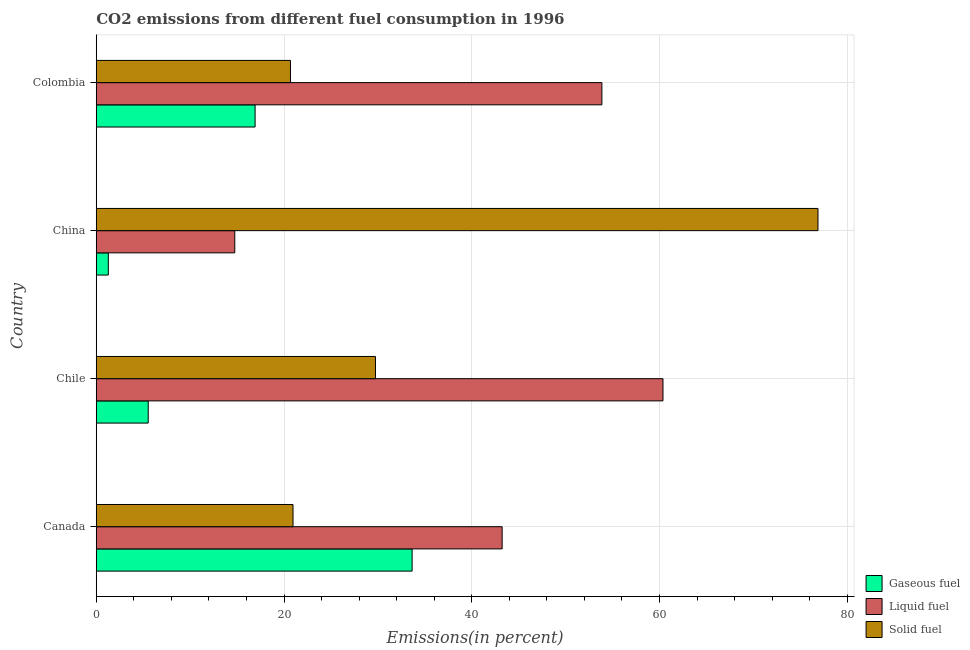How many groups of bars are there?
Offer a terse response. 4. Are the number of bars on each tick of the Y-axis equal?
Keep it short and to the point. Yes. How many bars are there on the 4th tick from the top?
Make the answer very short. 3. How many bars are there on the 2nd tick from the bottom?
Make the answer very short. 3. What is the label of the 3rd group of bars from the top?
Your answer should be compact. Chile. What is the percentage of liquid fuel emission in China?
Offer a terse response. 14.76. Across all countries, what is the maximum percentage of gaseous fuel emission?
Your response must be concise. 33.65. Across all countries, what is the minimum percentage of liquid fuel emission?
Your answer should be compact. 14.76. In which country was the percentage of gaseous fuel emission maximum?
Your answer should be compact. Canada. What is the total percentage of liquid fuel emission in the graph?
Your answer should be very brief. 172.23. What is the difference between the percentage of solid fuel emission in Canada and that in Colombia?
Ensure brevity in your answer.  0.27. What is the difference between the percentage of liquid fuel emission in Colombia and the percentage of solid fuel emission in Canada?
Provide a short and direct response. 32.9. What is the average percentage of liquid fuel emission per country?
Ensure brevity in your answer.  43.06. What is the difference between the percentage of solid fuel emission and percentage of liquid fuel emission in China?
Provide a short and direct response. 62.13. What is the ratio of the percentage of gaseous fuel emission in Chile to that in China?
Make the answer very short. 4.31. Is the difference between the percentage of liquid fuel emission in China and Colombia greater than the difference between the percentage of solid fuel emission in China and Colombia?
Your answer should be very brief. No. What is the difference between the highest and the second highest percentage of liquid fuel emission?
Provide a succinct answer. 6.51. What is the difference between the highest and the lowest percentage of liquid fuel emission?
Ensure brevity in your answer.  45.62. In how many countries, is the percentage of solid fuel emission greater than the average percentage of solid fuel emission taken over all countries?
Your response must be concise. 1. Is the sum of the percentage of gaseous fuel emission in China and Colombia greater than the maximum percentage of solid fuel emission across all countries?
Ensure brevity in your answer.  No. What does the 3rd bar from the top in Chile represents?
Provide a short and direct response. Gaseous fuel. What does the 1st bar from the bottom in Chile represents?
Give a very brief answer. Gaseous fuel. Is it the case that in every country, the sum of the percentage of gaseous fuel emission and percentage of liquid fuel emission is greater than the percentage of solid fuel emission?
Offer a terse response. No. How many bars are there?
Keep it short and to the point. 12. Are all the bars in the graph horizontal?
Provide a succinct answer. Yes. Are the values on the major ticks of X-axis written in scientific E-notation?
Give a very brief answer. No. Does the graph contain any zero values?
Make the answer very short. No. How many legend labels are there?
Make the answer very short. 3. What is the title of the graph?
Provide a succinct answer. CO2 emissions from different fuel consumption in 1996. What is the label or title of the X-axis?
Offer a very short reply. Emissions(in percent). What is the Emissions(in percent) in Gaseous fuel in Canada?
Offer a very short reply. 33.65. What is the Emissions(in percent) in Liquid fuel in Canada?
Provide a short and direct response. 43.24. What is the Emissions(in percent) in Solid fuel in Canada?
Offer a terse response. 20.96. What is the Emissions(in percent) of Gaseous fuel in Chile?
Your answer should be compact. 5.53. What is the Emissions(in percent) of Liquid fuel in Chile?
Your answer should be compact. 60.37. What is the Emissions(in percent) in Solid fuel in Chile?
Offer a very short reply. 29.74. What is the Emissions(in percent) in Gaseous fuel in China?
Give a very brief answer. 1.29. What is the Emissions(in percent) of Liquid fuel in China?
Keep it short and to the point. 14.76. What is the Emissions(in percent) in Solid fuel in China?
Give a very brief answer. 76.88. What is the Emissions(in percent) of Gaseous fuel in Colombia?
Offer a very short reply. 16.92. What is the Emissions(in percent) of Liquid fuel in Colombia?
Make the answer very short. 53.87. What is the Emissions(in percent) of Solid fuel in Colombia?
Your answer should be very brief. 20.69. Across all countries, what is the maximum Emissions(in percent) of Gaseous fuel?
Make the answer very short. 33.65. Across all countries, what is the maximum Emissions(in percent) in Liquid fuel?
Your answer should be very brief. 60.37. Across all countries, what is the maximum Emissions(in percent) in Solid fuel?
Provide a succinct answer. 76.88. Across all countries, what is the minimum Emissions(in percent) of Gaseous fuel?
Provide a succinct answer. 1.29. Across all countries, what is the minimum Emissions(in percent) of Liquid fuel?
Keep it short and to the point. 14.76. Across all countries, what is the minimum Emissions(in percent) in Solid fuel?
Offer a very short reply. 20.69. What is the total Emissions(in percent) of Gaseous fuel in the graph?
Keep it short and to the point. 57.39. What is the total Emissions(in percent) in Liquid fuel in the graph?
Provide a short and direct response. 172.23. What is the total Emissions(in percent) in Solid fuel in the graph?
Offer a very short reply. 148.28. What is the difference between the Emissions(in percent) of Gaseous fuel in Canada and that in Chile?
Your answer should be compact. 28.11. What is the difference between the Emissions(in percent) of Liquid fuel in Canada and that in Chile?
Give a very brief answer. -17.13. What is the difference between the Emissions(in percent) of Solid fuel in Canada and that in Chile?
Offer a terse response. -8.78. What is the difference between the Emissions(in percent) of Gaseous fuel in Canada and that in China?
Your response must be concise. 32.36. What is the difference between the Emissions(in percent) in Liquid fuel in Canada and that in China?
Keep it short and to the point. 28.48. What is the difference between the Emissions(in percent) of Solid fuel in Canada and that in China?
Your answer should be very brief. -55.92. What is the difference between the Emissions(in percent) of Gaseous fuel in Canada and that in Colombia?
Make the answer very short. 16.73. What is the difference between the Emissions(in percent) of Liquid fuel in Canada and that in Colombia?
Ensure brevity in your answer.  -10.63. What is the difference between the Emissions(in percent) of Solid fuel in Canada and that in Colombia?
Your response must be concise. 0.27. What is the difference between the Emissions(in percent) in Gaseous fuel in Chile and that in China?
Your answer should be compact. 4.25. What is the difference between the Emissions(in percent) of Liquid fuel in Chile and that in China?
Offer a very short reply. 45.62. What is the difference between the Emissions(in percent) in Solid fuel in Chile and that in China?
Ensure brevity in your answer.  -47.14. What is the difference between the Emissions(in percent) of Gaseous fuel in Chile and that in Colombia?
Offer a very short reply. -11.39. What is the difference between the Emissions(in percent) in Liquid fuel in Chile and that in Colombia?
Ensure brevity in your answer.  6.51. What is the difference between the Emissions(in percent) in Solid fuel in Chile and that in Colombia?
Provide a short and direct response. 9.05. What is the difference between the Emissions(in percent) of Gaseous fuel in China and that in Colombia?
Make the answer very short. -15.64. What is the difference between the Emissions(in percent) in Liquid fuel in China and that in Colombia?
Make the answer very short. -39.11. What is the difference between the Emissions(in percent) of Solid fuel in China and that in Colombia?
Give a very brief answer. 56.2. What is the difference between the Emissions(in percent) in Gaseous fuel in Canada and the Emissions(in percent) in Liquid fuel in Chile?
Your answer should be very brief. -26.73. What is the difference between the Emissions(in percent) in Gaseous fuel in Canada and the Emissions(in percent) in Solid fuel in Chile?
Provide a short and direct response. 3.9. What is the difference between the Emissions(in percent) of Liquid fuel in Canada and the Emissions(in percent) of Solid fuel in Chile?
Ensure brevity in your answer.  13.49. What is the difference between the Emissions(in percent) in Gaseous fuel in Canada and the Emissions(in percent) in Liquid fuel in China?
Your response must be concise. 18.89. What is the difference between the Emissions(in percent) of Gaseous fuel in Canada and the Emissions(in percent) of Solid fuel in China?
Give a very brief answer. -43.24. What is the difference between the Emissions(in percent) in Liquid fuel in Canada and the Emissions(in percent) in Solid fuel in China?
Ensure brevity in your answer.  -33.65. What is the difference between the Emissions(in percent) of Gaseous fuel in Canada and the Emissions(in percent) of Liquid fuel in Colombia?
Offer a terse response. -20.22. What is the difference between the Emissions(in percent) in Gaseous fuel in Canada and the Emissions(in percent) in Solid fuel in Colombia?
Your response must be concise. 12.96. What is the difference between the Emissions(in percent) in Liquid fuel in Canada and the Emissions(in percent) in Solid fuel in Colombia?
Give a very brief answer. 22.55. What is the difference between the Emissions(in percent) of Gaseous fuel in Chile and the Emissions(in percent) of Liquid fuel in China?
Keep it short and to the point. -9.22. What is the difference between the Emissions(in percent) of Gaseous fuel in Chile and the Emissions(in percent) of Solid fuel in China?
Your response must be concise. -71.35. What is the difference between the Emissions(in percent) of Liquid fuel in Chile and the Emissions(in percent) of Solid fuel in China?
Ensure brevity in your answer.  -16.51. What is the difference between the Emissions(in percent) in Gaseous fuel in Chile and the Emissions(in percent) in Liquid fuel in Colombia?
Ensure brevity in your answer.  -48.33. What is the difference between the Emissions(in percent) of Gaseous fuel in Chile and the Emissions(in percent) of Solid fuel in Colombia?
Make the answer very short. -15.15. What is the difference between the Emissions(in percent) of Liquid fuel in Chile and the Emissions(in percent) of Solid fuel in Colombia?
Provide a short and direct response. 39.68. What is the difference between the Emissions(in percent) of Gaseous fuel in China and the Emissions(in percent) of Liquid fuel in Colombia?
Give a very brief answer. -52.58. What is the difference between the Emissions(in percent) of Gaseous fuel in China and the Emissions(in percent) of Solid fuel in Colombia?
Offer a very short reply. -19.4. What is the difference between the Emissions(in percent) of Liquid fuel in China and the Emissions(in percent) of Solid fuel in Colombia?
Provide a short and direct response. -5.93. What is the average Emissions(in percent) in Gaseous fuel per country?
Your answer should be compact. 14.35. What is the average Emissions(in percent) of Liquid fuel per country?
Keep it short and to the point. 43.06. What is the average Emissions(in percent) in Solid fuel per country?
Provide a succinct answer. 37.07. What is the difference between the Emissions(in percent) in Gaseous fuel and Emissions(in percent) in Liquid fuel in Canada?
Provide a succinct answer. -9.59. What is the difference between the Emissions(in percent) of Gaseous fuel and Emissions(in percent) of Solid fuel in Canada?
Ensure brevity in your answer.  12.69. What is the difference between the Emissions(in percent) of Liquid fuel and Emissions(in percent) of Solid fuel in Canada?
Provide a short and direct response. 22.28. What is the difference between the Emissions(in percent) of Gaseous fuel and Emissions(in percent) of Liquid fuel in Chile?
Offer a very short reply. -54.84. What is the difference between the Emissions(in percent) of Gaseous fuel and Emissions(in percent) of Solid fuel in Chile?
Ensure brevity in your answer.  -24.21. What is the difference between the Emissions(in percent) in Liquid fuel and Emissions(in percent) in Solid fuel in Chile?
Your answer should be very brief. 30.63. What is the difference between the Emissions(in percent) in Gaseous fuel and Emissions(in percent) in Liquid fuel in China?
Offer a very short reply. -13.47. What is the difference between the Emissions(in percent) in Gaseous fuel and Emissions(in percent) in Solid fuel in China?
Keep it short and to the point. -75.6. What is the difference between the Emissions(in percent) in Liquid fuel and Emissions(in percent) in Solid fuel in China?
Your answer should be very brief. -62.13. What is the difference between the Emissions(in percent) in Gaseous fuel and Emissions(in percent) in Liquid fuel in Colombia?
Provide a succinct answer. -36.94. What is the difference between the Emissions(in percent) of Gaseous fuel and Emissions(in percent) of Solid fuel in Colombia?
Offer a very short reply. -3.77. What is the difference between the Emissions(in percent) of Liquid fuel and Emissions(in percent) of Solid fuel in Colombia?
Give a very brief answer. 33.18. What is the ratio of the Emissions(in percent) in Gaseous fuel in Canada to that in Chile?
Your answer should be very brief. 6.08. What is the ratio of the Emissions(in percent) of Liquid fuel in Canada to that in Chile?
Offer a very short reply. 0.72. What is the ratio of the Emissions(in percent) in Solid fuel in Canada to that in Chile?
Provide a short and direct response. 0.7. What is the ratio of the Emissions(in percent) of Gaseous fuel in Canada to that in China?
Offer a very short reply. 26.18. What is the ratio of the Emissions(in percent) of Liquid fuel in Canada to that in China?
Your answer should be compact. 2.93. What is the ratio of the Emissions(in percent) of Solid fuel in Canada to that in China?
Make the answer very short. 0.27. What is the ratio of the Emissions(in percent) of Gaseous fuel in Canada to that in Colombia?
Offer a very short reply. 1.99. What is the ratio of the Emissions(in percent) of Liquid fuel in Canada to that in Colombia?
Give a very brief answer. 0.8. What is the ratio of the Emissions(in percent) of Solid fuel in Canada to that in Colombia?
Offer a very short reply. 1.01. What is the ratio of the Emissions(in percent) in Gaseous fuel in Chile to that in China?
Offer a terse response. 4.31. What is the ratio of the Emissions(in percent) of Liquid fuel in Chile to that in China?
Make the answer very short. 4.09. What is the ratio of the Emissions(in percent) of Solid fuel in Chile to that in China?
Give a very brief answer. 0.39. What is the ratio of the Emissions(in percent) in Gaseous fuel in Chile to that in Colombia?
Ensure brevity in your answer.  0.33. What is the ratio of the Emissions(in percent) of Liquid fuel in Chile to that in Colombia?
Ensure brevity in your answer.  1.12. What is the ratio of the Emissions(in percent) of Solid fuel in Chile to that in Colombia?
Keep it short and to the point. 1.44. What is the ratio of the Emissions(in percent) in Gaseous fuel in China to that in Colombia?
Offer a terse response. 0.08. What is the ratio of the Emissions(in percent) of Liquid fuel in China to that in Colombia?
Provide a short and direct response. 0.27. What is the ratio of the Emissions(in percent) of Solid fuel in China to that in Colombia?
Make the answer very short. 3.72. What is the difference between the highest and the second highest Emissions(in percent) of Gaseous fuel?
Offer a very short reply. 16.73. What is the difference between the highest and the second highest Emissions(in percent) of Liquid fuel?
Make the answer very short. 6.51. What is the difference between the highest and the second highest Emissions(in percent) in Solid fuel?
Your answer should be very brief. 47.14. What is the difference between the highest and the lowest Emissions(in percent) in Gaseous fuel?
Offer a very short reply. 32.36. What is the difference between the highest and the lowest Emissions(in percent) in Liquid fuel?
Provide a succinct answer. 45.62. What is the difference between the highest and the lowest Emissions(in percent) of Solid fuel?
Give a very brief answer. 56.2. 